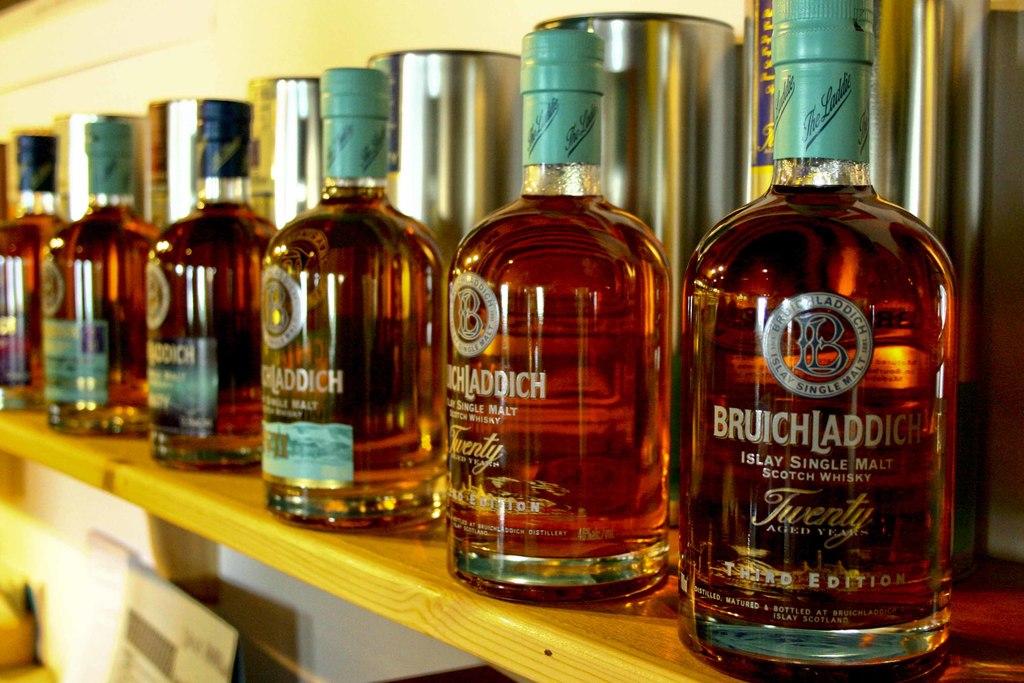What is the brand of the first bottle/?
Your response must be concise. Bruichladdich. 